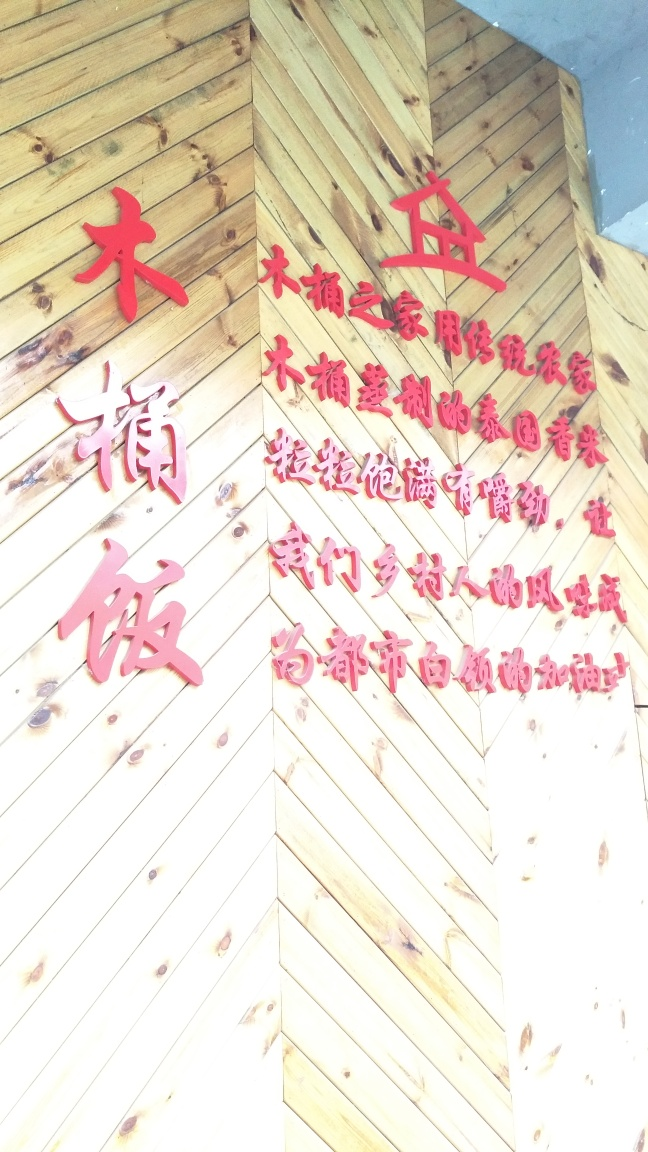Is the overall clarity of the image average? While the image exhibits a reasonable degree of detail, there is noticeable overexposure, causing a loss of clarity in some areas. Considering these factors, I would rate the clarity as somewhat above average, despite some imperfections. 